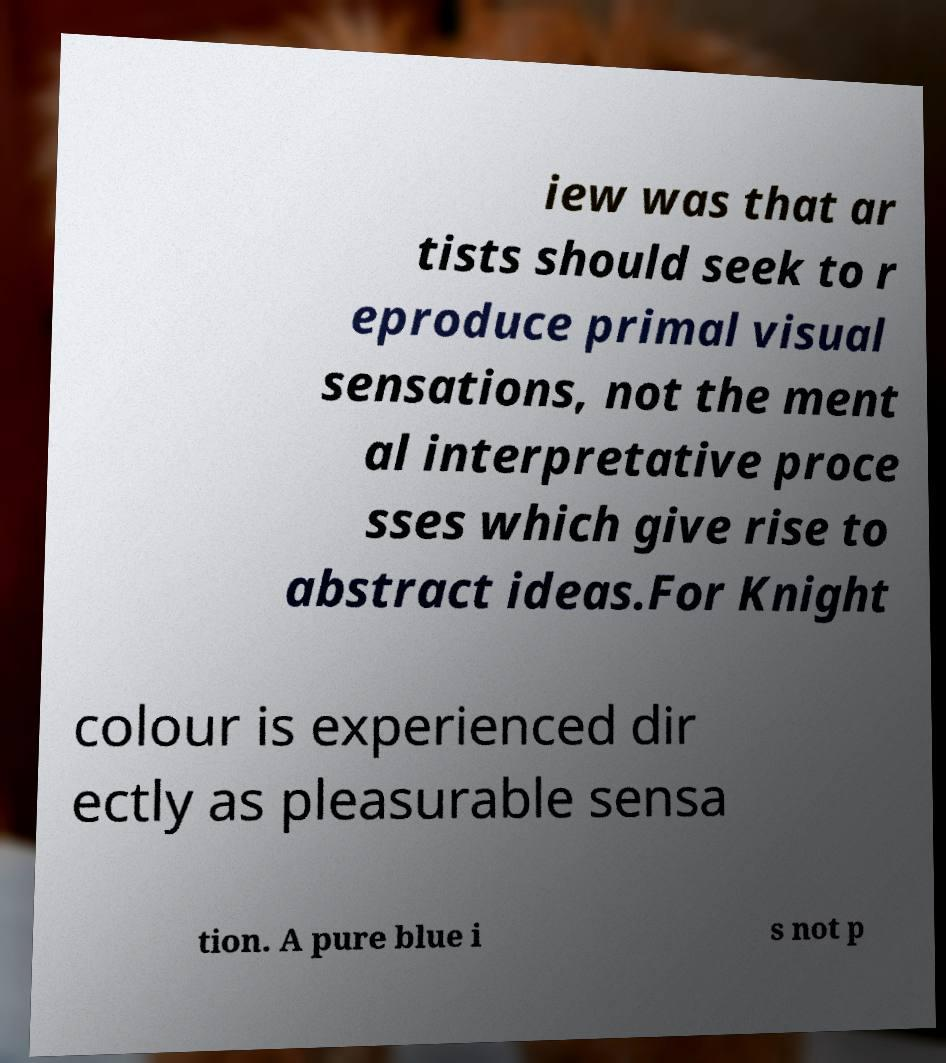Could you assist in decoding the text presented in this image and type it out clearly? iew was that ar tists should seek to r eproduce primal visual sensations, not the ment al interpretative proce sses which give rise to abstract ideas.For Knight colour is experienced dir ectly as pleasurable sensa tion. A pure blue i s not p 